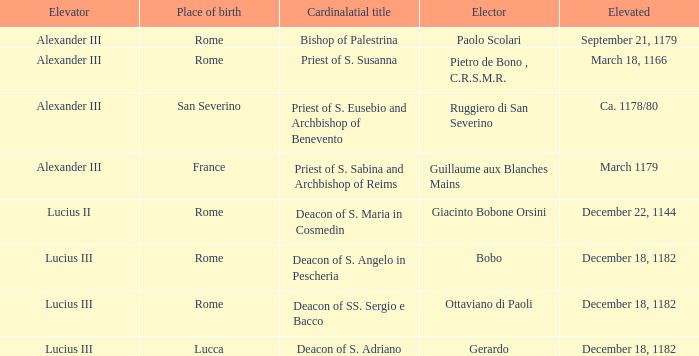Can you parse all the data within this table? {'header': ['Elevator', 'Place of birth', 'Cardinalatial title', 'Elector', 'Elevated'], 'rows': [['Alexander III', 'Rome', 'Bishop of Palestrina', 'Paolo Scolari', 'September 21, 1179'], ['Alexander III', 'Rome', 'Priest of S. Susanna', 'Pietro de Bono , C.R.S.M.R.', 'March 18, 1166'], ['Alexander III', 'San Severino', 'Priest of S. Eusebio and Archbishop of Benevento', 'Ruggiero di San Severino', 'Ca. 1178/80'], ['Alexander III', 'France', 'Priest of S. Sabina and Archbishop of Reims', 'Guillaume aux Blanches Mains', 'March 1179'], ['Lucius II', 'Rome', 'Deacon of S. Maria in Cosmedin', 'Giacinto Bobone Orsini', 'December 22, 1144'], ['Lucius III', 'Rome', 'Deacon of S. Angelo in Pescheria', 'Bobo', 'December 18, 1182'], ['Lucius III', 'Rome', 'Deacon of SS. Sergio e Bacco', 'Ottaviano di Paoli', 'December 18, 1182'], ['Lucius III', 'Lucca', 'Deacon of S. Adriano', 'Gerardo', 'December 18, 1182']]} What is the Elevator of the Elected Elevated on September 21, 1179? Alexander III. 